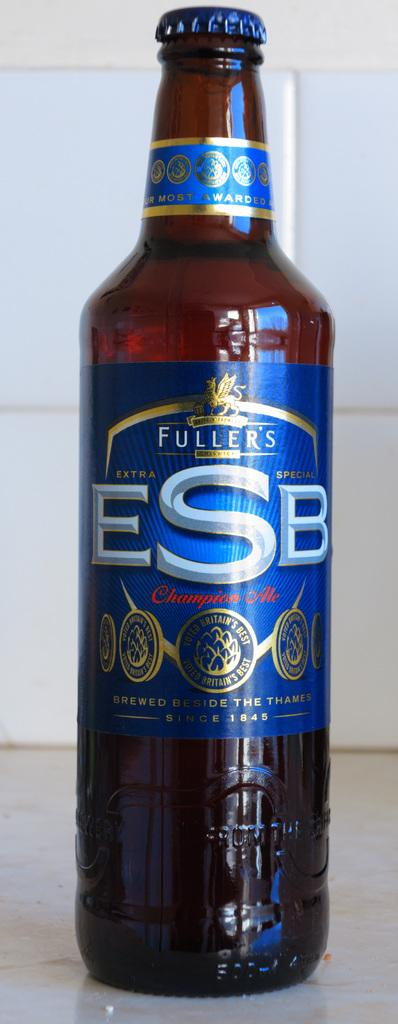<image>
Offer a succinct explanation of the picture presented. Fuller's ESP Champion Ale that is Brewed beside the Thames. 